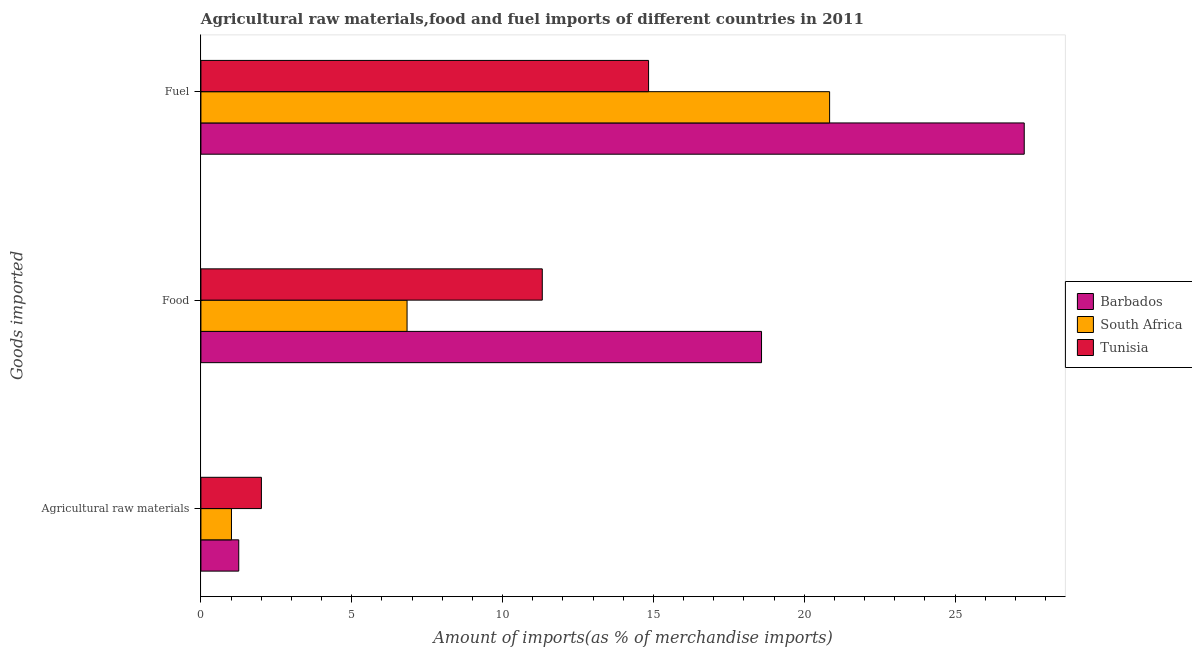How many groups of bars are there?
Provide a short and direct response. 3. Are the number of bars per tick equal to the number of legend labels?
Offer a terse response. Yes. How many bars are there on the 1st tick from the top?
Provide a succinct answer. 3. What is the label of the 2nd group of bars from the top?
Offer a very short reply. Food. What is the percentage of raw materials imports in Tunisia?
Offer a very short reply. 2.01. Across all countries, what is the maximum percentage of raw materials imports?
Make the answer very short. 2.01. Across all countries, what is the minimum percentage of food imports?
Your answer should be very brief. 6.83. In which country was the percentage of raw materials imports maximum?
Provide a short and direct response. Tunisia. In which country was the percentage of raw materials imports minimum?
Your answer should be compact. South Africa. What is the total percentage of fuel imports in the graph?
Provide a succinct answer. 62.98. What is the difference between the percentage of fuel imports in South Africa and that in Barbados?
Offer a terse response. -6.45. What is the difference between the percentage of raw materials imports in Tunisia and the percentage of fuel imports in Barbados?
Offer a very short reply. -25.29. What is the average percentage of raw materials imports per country?
Your answer should be very brief. 1.42. What is the difference between the percentage of food imports and percentage of raw materials imports in South Africa?
Offer a terse response. 5.82. What is the ratio of the percentage of food imports in South Africa to that in Barbados?
Your answer should be compact. 0.37. What is the difference between the highest and the second highest percentage of fuel imports?
Ensure brevity in your answer.  6.45. What is the difference between the highest and the lowest percentage of food imports?
Ensure brevity in your answer.  11.75. Is the sum of the percentage of food imports in Tunisia and Barbados greater than the maximum percentage of fuel imports across all countries?
Provide a short and direct response. Yes. What does the 1st bar from the top in Agricultural raw materials represents?
Provide a short and direct response. Tunisia. What does the 1st bar from the bottom in Fuel represents?
Offer a very short reply. Barbados. Is it the case that in every country, the sum of the percentage of raw materials imports and percentage of food imports is greater than the percentage of fuel imports?
Make the answer very short. No. How many countries are there in the graph?
Give a very brief answer. 3. Does the graph contain any zero values?
Your answer should be very brief. No. Does the graph contain grids?
Keep it short and to the point. No. What is the title of the graph?
Give a very brief answer. Agricultural raw materials,food and fuel imports of different countries in 2011. Does "Moldova" appear as one of the legend labels in the graph?
Offer a terse response. No. What is the label or title of the X-axis?
Give a very brief answer. Amount of imports(as % of merchandise imports). What is the label or title of the Y-axis?
Your answer should be compact. Goods imported. What is the Amount of imports(as % of merchandise imports) of Barbados in Agricultural raw materials?
Offer a very short reply. 1.25. What is the Amount of imports(as % of merchandise imports) in South Africa in Agricultural raw materials?
Keep it short and to the point. 1.01. What is the Amount of imports(as % of merchandise imports) of Tunisia in Agricultural raw materials?
Offer a terse response. 2.01. What is the Amount of imports(as % of merchandise imports) in Barbados in Food?
Keep it short and to the point. 18.59. What is the Amount of imports(as % of merchandise imports) of South Africa in Food?
Keep it short and to the point. 6.83. What is the Amount of imports(as % of merchandise imports) in Tunisia in Food?
Provide a short and direct response. 11.32. What is the Amount of imports(as % of merchandise imports) in Barbados in Fuel?
Your response must be concise. 27.3. What is the Amount of imports(as % of merchandise imports) of South Africa in Fuel?
Your answer should be very brief. 20.84. What is the Amount of imports(as % of merchandise imports) in Tunisia in Fuel?
Give a very brief answer. 14.84. Across all Goods imported, what is the maximum Amount of imports(as % of merchandise imports) of Barbados?
Your answer should be compact. 27.3. Across all Goods imported, what is the maximum Amount of imports(as % of merchandise imports) in South Africa?
Your answer should be compact. 20.84. Across all Goods imported, what is the maximum Amount of imports(as % of merchandise imports) in Tunisia?
Keep it short and to the point. 14.84. Across all Goods imported, what is the minimum Amount of imports(as % of merchandise imports) in Barbados?
Provide a short and direct response. 1.25. Across all Goods imported, what is the minimum Amount of imports(as % of merchandise imports) of South Africa?
Provide a succinct answer. 1.01. Across all Goods imported, what is the minimum Amount of imports(as % of merchandise imports) of Tunisia?
Provide a short and direct response. 2.01. What is the total Amount of imports(as % of merchandise imports) in Barbados in the graph?
Offer a terse response. 47.14. What is the total Amount of imports(as % of merchandise imports) of South Africa in the graph?
Provide a succinct answer. 28.69. What is the total Amount of imports(as % of merchandise imports) of Tunisia in the graph?
Your response must be concise. 28.16. What is the difference between the Amount of imports(as % of merchandise imports) in Barbados in Agricultural raw materials and that in Food?
Make the answer very short. -17.33. What is the difference between the Amount of imports(as % of merchandise imports) in South Africa in Agricultural raw materials and that in Food?
Make the answer very short. -5.82. What is the difference between the Amount of imports(as % of merchandise imports) in Tunisia in Agricultural raw materials and that in Food?
Keep it short and to the point. -9.31. What is the difference between the Amount of imports(as % of merchandise imports) in Barbados in Agricultural raw materials and that in Fuel?
Give a very brief answer. -26.04. What is the difference between the Amount of imports(as % of merchandise imports) of South Africa in Agricultural raw materials and that in Fuel?
Provide a succinct answer. -19.83. What is the difference between the Amount of imports(as % of merchandise imports) in Tunisia in Agricultural raw materials and that in Fuel?
Your answer should be compact. -12.84. What is the difference between the Amount of imports(as % of merchandise imports) of Barbados in Food and that in Fuel?
Keep it short and to the point. -8.71. What is the difference between the Amount of imports(as % of merchandise imports) in South Africa in Food and that in Fuel?
Keep it short and to the point. -14.01. What is the difference between the Amount of imports(as % of merchandise imports) in Tunisia in Food and that in Fuel?
Give a very brief answer. -3.52. What is the difference between the Amount of imports(as % of merchandise imports) in Barbados in Agricultural raw materials and the Amount of imports(as % of merchandise imports) in South Africa in Food?
Offer a terse response. -5.58. What is the difference between the Amount of imports(as % of merchandise imports) in Barbados in Agricultural raw materials and the Amount of imports(as % of merchandise imports) in Tunisia in Food?
Offer a very short reply. -10.06. What is the difference between the Amount of imports(as % of merchandise imports) in South Africa in Agricultural raw materials and the Amount of imports(as % of merchandise imports) in Tunisia in Food?
Your answer should be very brief. -10.3. What is the difference between the Amount of imports(as % of merchandise imports) in Barbados in Agricultural raw materials and the Amount of imports(as % of merchandise imports) in South Africa in Fuel?
Offer a very short reply. -19.59. What is the difference between the Amount of imports(as % of merchandise imports) in Barbados in Agricultural raw materials and the Amount of imports(as % of merchandise imports) in Tunisia in Fuel?
Make the answer very short. -13.59. What is the difference between the Amount of imports(as % of merchandise imports) in South Africa in Agricultural raw materials and the Amount of imports(as % of merchandise imports) in Tunisia in Fuel?
Your answer should be very brief. -13.83. What is the difference between the Amount of imports(as % of merchandise imports) in Barbados in Food and the Amount of imports(as % of merchandise imports) in South Africa in Fuel?
Keep it short and to the point. -2.26. What is the difference between the Amount of imports(as % of merchandise imports) in Barbados in Food and the Amount of imports(as % of merchandise imports) in Tunisia in Fuel?
Your response must be concise. 3.75. What is the difference between the Amount of imports(as % of merchandise imports) of South Africa in Food and the Amount of imports(as % of merchandise imports) of Tunisia in Fuel?
Make the answer very short. -8.01. What is the average Amount of imports(as % of merchandise imports) in Barbados per Goods imported?
Make the answer very short. 15.71. What is the average Amount of imports(as % of merchandise imports) in South Africa per Goods imported?
Your response must be concise. 9.56. What is the average Amount of imports(as % of merchandise imports) of Tunisia per Goods imported?
Offer a very short reply. 9.39. What is the difference between the Amount of imports(as % of merchandise imports) in Barbados and Amount of imports(as % of merchandise imports) in South Africa in Agricultural raw materials?
Your answer should be compact. 0.24. What is the difference between the Amount of imports(as % of merchandise imports) in Barbados and Amount of imports(as % of merchandise imports) in Tunisia in Agricultural raw materials?
Keep it short and to the point. -0.75. What is the difference between the Amount of imports(as % of merchandise imports) in South Africa and Amount of imports(as % of merchandise imports) in Tunisia in Agricultural raw materials?
Provide a short and direct response. -0.99. What is the difference between the Amount of imports(as % of merchandise imports) of Barbados and Amount of imports(as % of merchandise imports) of South Africa in Food?
Offer a terse response. 11.75. What is the difference between the Amount of imports(as % of merchandise imports) of Barbados and Amount of imports(as % of merchandise imports) of Tunisia in Food?
Keep it short and to the point. 7.27. What is the difference between the Amount of imports(as % of merchandise imports) of South Africa and Amount of imports(as % of merchandise imports) of Tunisia in Food?
Offer a very short reply. -4.48. What is the difference between the Amount of imports(as % of merchandise imports) of Barbados and Amount of imports(as % of merchandise imports) of South Africa in Fuel?
Your answer should be compact. 6.45. What is the difference between the Amount of imports(as % of merchandise imports) in Barbados and Amount of imports(as % of merchandise imports) in Tunisia in Fuel?
Provide a succinct answer. 12.45. What is the difference between the Amount of imports(as % of merchandise imports) in South Africa and Amount of imports(as % of merchandise imports) in Tunisia in Fuel?
Your answer should be very brief. 6. What is the ratio of the Amount of imports(as % of merchandise imports) of Barbados in Agricultural raw materials to that in Food?
Offer a terse response. 0.07. What is the ratio of the Amount of imports(as % of merchandise imports) of South Africa in Agricultural raw materials to that in Food?
Give a very brief answer. 0.15. What is the ratio of the Amount of imports(as % of merchandise imports) of Tunisia in Agricultural raw materials to that in Food?
Offer a very short reply. 0.18. What is the ratio of the Amount of imports(as % of merchandise imports) of Barbados in Agricultural raw materials to that in Fuel?
Give a very brief answer. 0.05. What is the ratio of the Amount of imports(as % of merchandise imports) in South Africa in Agricultural raw materials to that in Fuel?
Keep it short and to the point. 0.05. What is the ratio of the Amount of imports(as % of merchandise imports) in Tunisia in Agricultural raw materials to that in Fuel?
Provide a short and direct response. 0.14. What is the ratio of the Amount of imports(as % of merchandise imports) of Barbados in Food to that in Fuel?
Your answer should be compact. 0.68. What is the ratio of the Amount of imports(as % of merchandise imports) in South Africa in Food to that in Fuel?
Give a very brief answer. 0.33. What is the ratio of the Amount of imports(as % of merchandise imports) of Tunisia in Food to that in Fuel?
Offer a terse response. 0.76. What is the difference between the highest and the second highest Amount of imports(as % of merchandise imports) of Barbados?
Offer a terse response. 8.71. What is the difference between the highest and the second highest Amount of imports(as % of merchandise imports) in South Africa?
Ensure brevity in your answer.  14.01. What is the difference between the highest and the second highest Amount of imports(as % of merchandise imports) of Tunisia?
Provide a short and direct response. 3.52. What is the difference between the highest and the lowest Amount of imports(as % of merchandise imports) in Barbados?
Provide a succinct answer. 26.04. What is the difference between the highest and the lowest Amount of imports(as % of merchandise imports) in South Africa?
Keep it short and to the point. 19.83. What is the difference between the highest and the lowest Amount of imports(as % of merchandise imports) of Tunisia?
Your response must be concise. 12.84. 